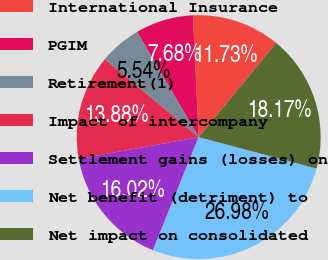Convert chart. <chart><loc_0><loc_0><loc_500><loc_500><pie_chart><fcel>International Insurance<fcel>PGIM<fcel>Retirement(1)<fcel>Impact of intercompany<fcel>Settlement gains (losses) on<fcel>Net benefit (detriment) to<fcel>Net impact on consolidated<nl><fcel>11.73%<fcel>7.68%<fcel>5.54%<fcel>13.88%<fcel>16.02%<fcel>26.98%<fcel>18.17%<nl></chart> 